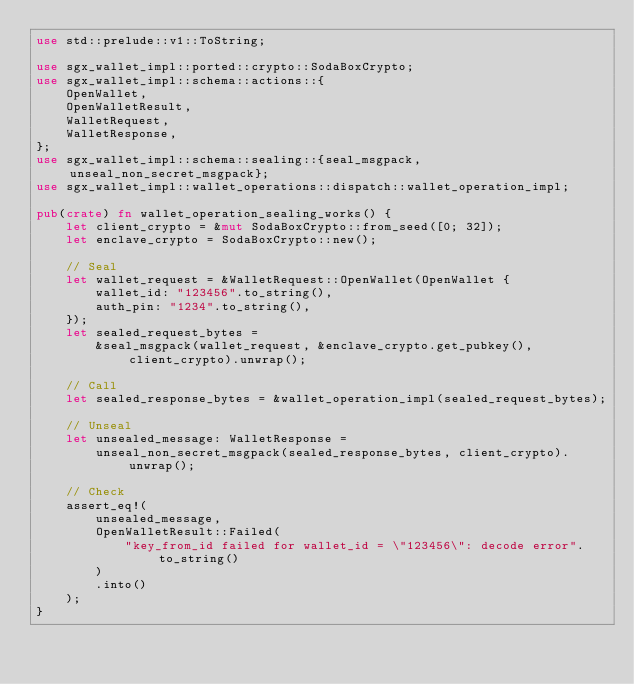<code> <loc_0><loc_0><loc_500><loc_500><_Rust_>use std::prelude::v1::ToString;

use sgx_wallet_impl::ported::crypto::SodaBoxCrypto;
use sgx_wallet_impl::schema::actions::{
    OpenWallet,
    OpenWalletResult,
    WalletRequest,
    WalletResponse,
};
use sgx_wallet_impl::schema::sealing::{seal_msgpack, unseal_non_secret_msgpack};
use sgx_wallet_impl::wallet_operations::dispatch::wallet_operation_impl;

pub(crate) fn wallet_operation_sealing_works() {
    let client_crypto = &mut SodaBoxCrypto::from_seed([0; 32]);
    let enclave_crypto = SodaBoxCrypto::new();

    // Seal
    let wallet_request = &WalletRequest::OpenWallet(OpenWallet {
        wallet_id: "123456".to_string(),
        auth_pin: "1234".to_string(),
    });
    let sealed_request_bytes =
        &seal_msgpack(wallet_request, &enclave_crypto.get_pubkey(), client_crypto).unwrap();

    // Call
    let sealed_response_bytes = &wallet_operation_impl(sealed_request_bytes);

    // Unseal
    let unsealed_message: WalletResponse =
        unseal_non_secret_msgpack(sealed_response_bytes, client_crypto).unwrap();

    // Check
    assert_eq!(
        unsealed_message,
        OpenWalletResult::Failed(
            "key_from_id failed for wallet_id = \"123456\": decode error".to_string()
        )
        .into()
    );
}
</code> 